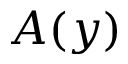Convert formula to latex. <formula><loc_0><loc_0><loc_500><loc_500>A ( y )</formula> 